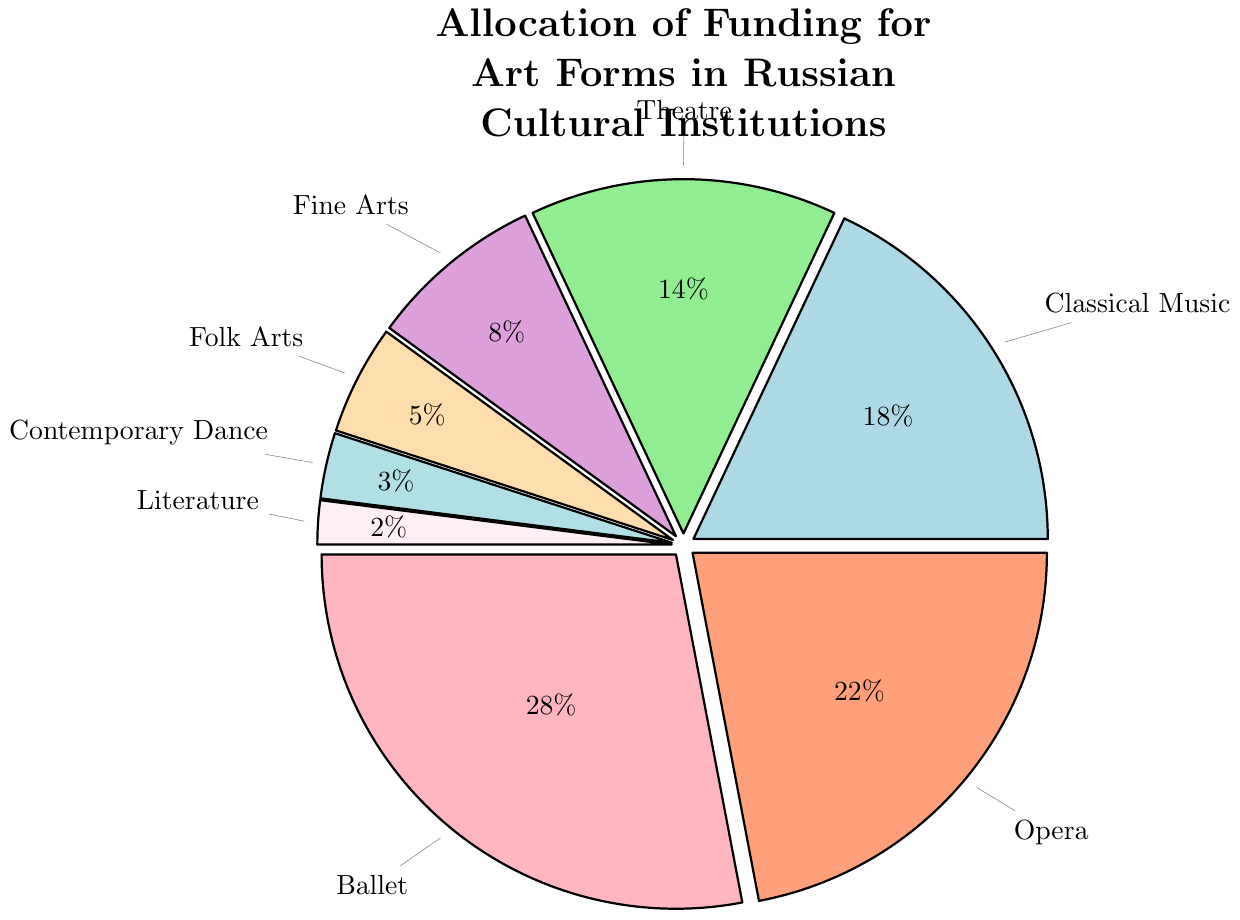What is the percentage allocation for Ballet? The percentage allocation for Ballet is provided directly in the pie chart's segment labeled "Ballet."
Answer: 28% How much more funding do Classical Music and Opera together receive compared to Theatre? First, sum the percentages of Classical Music (18%) and Opera (22%), which gives 40%. Then, subtract the percentage for Theatre (14%) from this sum: 40% - 14% = 26%.
Answer: 26% Which art form receives the least funding? The pie chart segment with the smallest percentage indicates the art form with the least funding. It is labeled "Literature" with 2%.
Answer: Literature What is the total percentage allocation for Fine Arts and Folk Arts? Add the percentages for Fine Arts (8%) and Folk Arts (5%): 8% + 5% = 13%.
Answer: 13% Are there any art forms that receive similar amounts of funding? Compare the segments' percentages—Classical Music (18%) and Theatre (14%) are relatively close in funding allocation.
Answer: Classical Music and Theatre What is the difference in funding allocation between Ballet and Contemporary Dance? Subtract the percentage for Contemporary Dance (3%) from the percentage for Ballet (28%): 28% - 3% = 25%.
Answer: 25% If funding for Contemporary Dance increased by 2%, what would its new percentage be, and which art form would it then equal in funding receiving? Increasing Contemporary Dance's current funding percentage (3%) by 2% results in 5%. This would make it equal to Folk Arts, which also receives 5%.
Answer: 5%, Folk Arts Is the sum of the funding allocations for Fine Arts, Folk Arts, and Literature greater or less than the allocation for Theatre? Sum the percentages for Fine Arts (8%), Folk Arts (5%), and Literature (2%): 8% + 5% + 2% = 15%, then compare it to Theatre's allocation (14%). 15% is greater than 14%.
Answer: Greater 